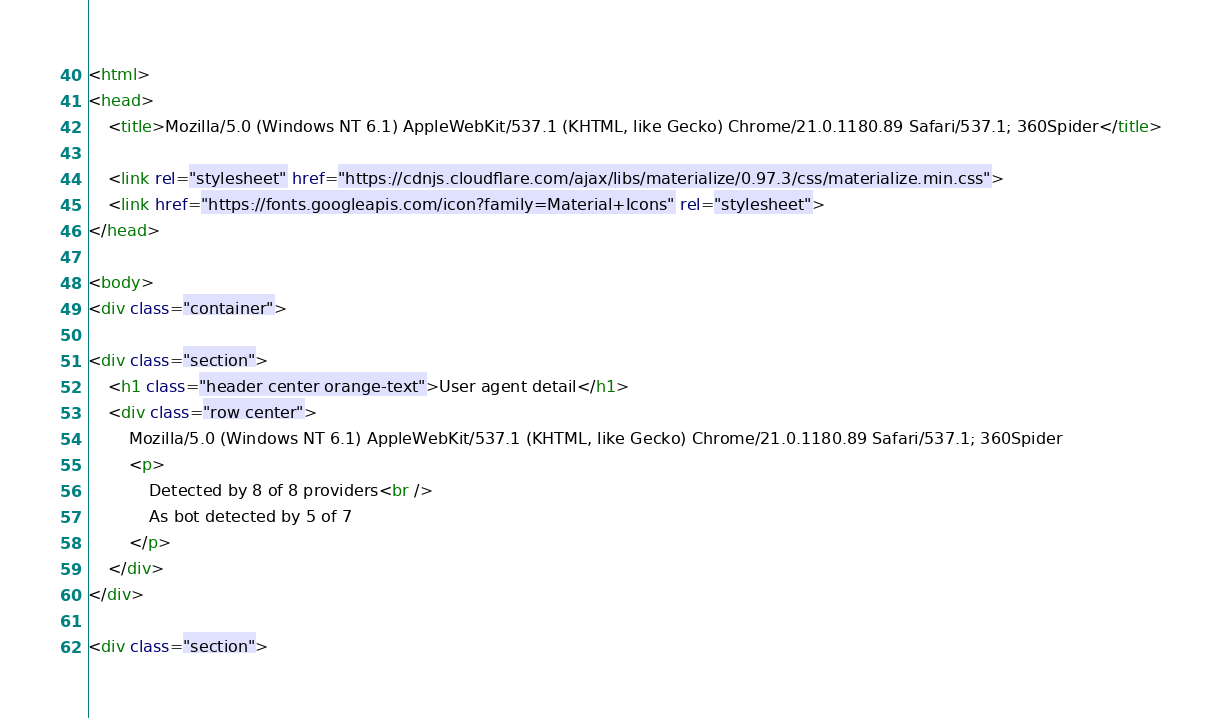Convert code to text. <code><loc_0><loc_0><loc_500><loc_500><_HTML_>
<html>
<head>
    <title>Mozilla/5.0 (Windows NT 6.1) AppleWebKit/537.1 (KHTML, like Gecko) Chrome/21.0.1180.89 Safari/537.1; 360Spider</title>
        
    <link rel="stylesheet" href="https://cdnjs.cloudflare.com/ajax/libs/materialize/0.97.3/css/materialize.min.css">
    <link href="https://fonts.googleapis.com/icon?family=Material+Icons" rel="stylesheet">
</head>
        
<body>
<div class="container">
    
<div class="section">
	<h1 class="header center orange-text">User agent detail</h1>
	<div class="row center">
        Mozilla/5.0 (Windows NT 6.1) AppleWebKit/537.1 (KHTML, like Gecko) Chrome/21.0.1180.89 Safari/537.1; 360Spider
        <p>
            Detected by 8 of 8 providers<br />
            As bot detected by 5 of 7
		</p>
	</div>
</div>   

<div class="section"></code> 